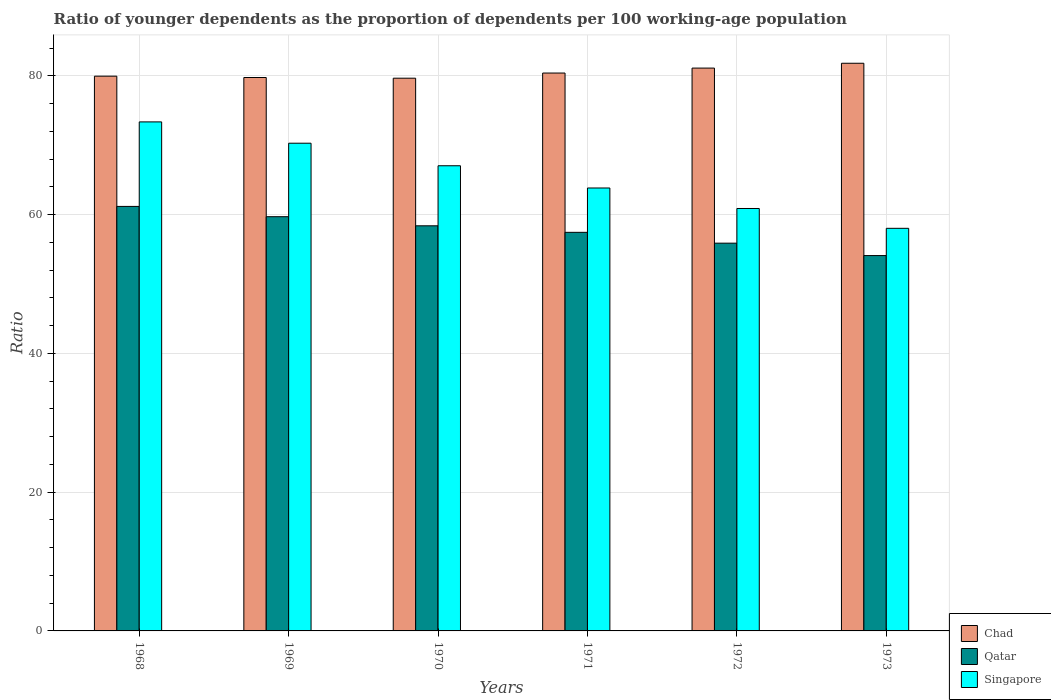Are the number of bars per tick equal to the number of legend labels?
Ensure brevity in your answer.  Yes. Are the number of bars on each tick of the X-axis equal?
Give a very brief answer. Yes. How many bars are there on the 1st tick from the left?
Offer a very short reply. 3. How many bars are there on the 6th tick from the right?
Provide a short and direct response. 3. What is the age dependency ratio(young) in Singapore in 1970?
Provide a short and direct response. 67.04. Across all years, what is the maximum age dependency ratio(young) in Qatar?
Make the answer very short. 61.18. Across all years, what is the minimum age dependency ratio(young) in Singapore?
Provide a succinct answer. 58.02. In which year was the age dependency ratio(young) in Singapore minimum?
Offer a very short reply. 1973. What is the total age dependency ratio(young) in Singapore in the graph?
Make the answer very short. 393.41. What is the difference between the age dependency ratio(young) in Chad in 1969 and that in 1971?
Provide a succinct answer. -0.64. What is the difference between the age dependency ratio(young) in Singapore in 1969 and the age dependency ratio(young) in Qatar in 1973?
Provide a short and direct response. 16.19. What is the average age dependency ratio(young) in Singapore per year?
Give a very brief answer. 65.57. In the year 1968, what is the difference between the age dependency ratio(young) in Qatar and age dependency ratio(young) in Chad?
Offer a terse response. -18.77. What is the ratio of the age dependency ratio(young) in Singapore in 1970 to that in 1971?
Your answer should be very brief. 1.05. Is the age dependency ratio(young) in Qatar in 1969 less than that in 1971?
Offer a very short reply. No. What is the difference between the highest and the second highest age dependency ratio(young) in Chad?
Ensure brevity in your answer.  0.7. What is the difference between the highest and the lowest age dependency ratio(young) in Chad?
Make the answer very short. 2.15. In how many years, is the age dependency ratio(young) in Qatar greater than the average age dependency ratio(young) in Qatar taken over all years?
Your answer should be very brief. 3. Is the sum of the age dependency ratio(young) in Qatar in 1968 and 1972 greater than the maximum age dependency ratio(young) in Singapore across all years?
Your response must be concise. Yes. What does the 2nd bar from the left in 1969 represents?
Make the answer very short. Qatar. What does the 1st bar from the right in 1968 represents?
Provide a succinct answer. Singapore. Is it the case that in every year, the sum of the age dependency ratio(young) in Chad and age dependency ratio(young) in Singapore is greater than the age dependency ratio(young) in Qatar?
Provide a succinct answer. Yes. How many bars are there?
Your response must be concise. 18. How many years are there in the graph?
Provide a succinct answer. 6. What is the difference between two consecutive major ticks on the Y-axis?
Provide a short and direct response. 20. Are the values on the major ticks of Y-axis written in scientific E-notation?
Provide a short and direct response. No. Where does the legend appear in the graph?
Your answer should be compact. Bottom right. How many legend labels are there?
Make the answer very short. 3. How are the legend labels stacked?
Your answer should be compact. Vertical. What is the title of the graph?
Your response must be concise. Ratio of younger dependents as the proportion of dependents per 100 working-age population. What is the label or title of the X-axis?
Offer a terse response. Years. What is the label or title of the Y-axis?
Offer a very short reply. Ratio. What is the Ratio of Chad in 1968?
Your answer should be compact. 79.95. What is the Ratio of Qatar in 1968?
Offer a very short reply. 61.18. What is the Ratio of Singapore in 1968?
Offer a terse response. 73.36. What is the Ratio of Chad in 1969?
Provide a short and direct response. 79.75. What is the Ratio of Qatar in 1969?
Ensure brevity in your answer.  59.69. What is the Ratio in Singapore in 1969?
Give a very brief answer. 70.28. What is the Ratio of Chad in 1970?
Keep it short and to the point. 79.65. What is the Ratio in Qatar in 1970?
Offer a very short reply. 58.38. What is the Ratio in Singapore in 1970?
Offer a very short reply. 67.04. What is the Ratio of Chad in 1971?
Make the answer very short. 80.4. What is the Ratio in Qatar in 1971?
Offer a terse response. 57.44. What is the Ratio in Singapore in 1971?
Provide a short and direct response. 63.83. What is the Ratio of Chad in 1972?
Provide a short and direct response. 81.11. What is the Ratio of Qatar in 1972?
Give a very brief answer. 55.88. What is the Ratio of Singapore in 1972?
Give a very brief answer. 60.88. What is the Ratio in Chad in 1973?
Ensure brevity in your answer.  81.81. What is the Ratio in Qatar in 1973?
Provide a short and direct response. 54.09. What is the Ratio in Singapore in 1973?
Make the answer very short. 58.02. Across all years, what is the maximum Ratio in Chad?
Provide a short and direct response. 81.81. Across all years, what is the maximum Ratio in Qatar?
Offer a very short reply. 61.18. Across all years, what is the maximum Ratio of Singapore?
Your response must be concise. 73.36. Across all years, what is the minimum Ratio of Chad?
Ensure brevity in your answer.  79.65. Across all years, what is the minimum Ratio in Qatar?
Provide a succinct answer. 54.09. Across all years, what is the minimum Ratio in Singapore?
Provide a succinct answer. 58.02. What is the total Ratio of Chad in the graph?
Your answer should be very brief. 482.67. What is the total Ratio of Qatar in the graph?
Give a very brief answer. 346.67. What is the total Ratio in Singapore in the graph?
Provide a succinct answer. 393.41. What is the difference between the Ratio of Chad in 1968 and that in 1969?
Offer a very short reply. 0.19. What is the difference between the Ratio of Qatar in 1968 and that in 1969?
Offer a terse response. 1.48. What is the difference between the Ratio of Singapore in 1968 and that in 1969?
Your response must be concise. 3.07. What is the difference between the Ratio in Chad in 1968 and that in 1970?
Your response must be concise. 0.29. What is the difference between the Ratio of Qatar in 1968 and that in 1970?
Make the answer very short. 2.8. What is the difference between the Ratio in Singapore in 1968 and that in 1970?
Keep it short and to the point. 6.32. What is the difference between the Ratio in Chad in 1968 and that in 1971?
Offer a very short reply. -0.45. What is the difference between the Ratio of Qatar in 1968 and that in 1971?
Give a very brief answer. 3.74. What is the difference between the Ratio of Singapore in 1968 and that in 1971?
Offer a terse response. 9.52. What is the difference between the Ratio in Chad in 1968 and that in 1972?
Make the answer very short. -1.16. What is the difference between the Ratio of Qatar in 1968 and that in 1972?
Ensure brevity in your answer.  5.3. What is the difference between the Ratio of Singapore in 1968 and that in 1972?
Offer a terse response. 12.48. What is the difference between the Ratio of Chad in 1968 and that in 1973?
Offer a very short reply. -1.86. What is the difference between the Ratio of Qatar in 1968 and that in 1973?
Offer a terse response. 7.09. What is the difference between the Ratio in Singapore in 1968 and that in 1973?
Your response must be concise. 15.34. What is the difference between the Ratio of Chad in 1969 and that in 1970?
Give a very brief answer. 0.1. What is the difference between the Ratio of Qatar in 1969 and that in 1970?
Give a very brief answer. 1.31. What is the difference between the Ratio of Singapore in 1969 and that in 1970?
Give a very brief answer. 3.25. What is the difference between the Ratio in Chad in 1969 and that in 1971?
Offer a terse response. -0.64. What is the difference between the Ratio of Qatar in 1969 and that in 1971?
Your answer should be very brief. 2.25. What is the difference between the Ratio in Singapore in 1969 and that in 1971?
Your response must be concise. 6.45. What is the difference between the Ratio in Chad in 1969 and that in 1972?
Ensure brevity in your answer.  -1.36. What is the difference between the Ratio of Qatar in 1969 and that in 1972?
Your answer should be compact. 3.81. What is the difference between the Ratio in Singapore in 1969 and that in 1972?
Make the answer very short. 9.41. What is the difference between the Ratio of Chad in 1969 and that in 1973?
Make the answer very short. -2.05. What is the difference between the Ratio in Qatar in 1969 and that in 1973?
Make the answer very short. 5.6. What is the difference between the Ratio of Singapore in 1969 and that in 1973?
Offer a terse response. 12.26. What is the difference between the Ratio in Chad in 1970 and that in 1971?
Offer a very short reply. -0.74. What is the difference between the Ratio of Qatar in 1970 and that in 1971?
Offer a very short reply. 0.94. What is the difference between the Ratio in Singapore in 1970 and that in 1971?
Make the answer very short. 3.2. What is the difference between the Ratio in Chad in 1970 and that in 1972?
Provide a succinct answer. -1.46. What is the difference between the Ratio of Qatar in 1970 and that in 1972?
Provide a succinct answer. 2.5. What is the difference between the Ratio in Singapore in 1970 and that in 1972?
Make the answer very short. 6.16. What is the difference between the Ratio of Chad in 1970 and that in 1973?
Provide a succinct answer. -2.15. What is the difference between the Ratio in Qatar in 1970 and that in 1973?
Offer a terse response. 4.29. What is the difference between the Ratio in Singapore in 1970 and that in 1973?
Your response must be concise. 9.02. What is the difference between the Ratio in Chad in 1971 and that in 1972?
Your answer should be very brief. -0.71. What is the difference between the Ratio of Qatar in 1971 and that in 1972?
Ensure brevity in your answer.  1.56. What is the difference between the Ratio in Singapore in 1971 and that in 1972?
Offer a terse response. 2.95. What is the difference between the Ratio of Chad in 1971 and that in 1973?
Provide a short and direct response. -1.41. What is the difference between the Ratio in Qatar in 1971 and that in 1973?
Ensure brevity in your answer.  3.35. What is the difference between the Ratio of Singapore in 1971 and that in 1973?
Keep it short and to the point. 5.81. What is the difference between the Ratio of Chad in 1972 and that in 1973?
Your response must be concise. -0.7. What is the difference between the Ratio of Qatar in 1972 and that in 1973?
Keep it short and to the point. 1.79. What is the difference between the Ratio of Singapore in 1972 and that in 1973?
Your answer should be very brief. 2.86. What is the difference between the Ratio in Chad in 1968 and the Ratio in Qatar in 1969?
Provide a succinct answer. 20.25. What is the difference between the Ratio in Chad in 1968 and the Ratio in Singapore in 1969?
Ensure brevity in your answer.  9.66. What is the difference between the Ratio of Qatar in 1968 and the Ratio of Singapore in 1969?
Keep it short and to the point. -9.11. What is the difference between the Ratio of Chad in 1968 and the Ratio of Qatar in 1970?
Give a very brief answer. 21.57. What is the difference between the Ratio in Chad in 1968 and the Ratio in Singapore in 1970?
Offer a very short reply. 12.91. What is the difference between the Ratio of Qatar in 1968 and the Ratio of Singapore in 1970?
Offer a terse response. -5.86. What is the difference between the Ratio in Chad in 1968 and the Ratio in Qatar in 1971?
Your answer should be very brief. 22.51. What is the difference between the Ratio of Chad in 1968 and the Ratio of Singapore in 1971?
Give a very brief answer. 16.12. What is the difference between the Ratio of Qatar in 1968 and the Ratio of Singapore in 1971?
Your answer should be compact. -2.65. What is the difference between the Ratio of Chad in 1968 and the Ratio of Qatar in 1972?
Make the answer very short. 24.07. What is the difference between the Ratio in Chad in 1968 and the Ratio in Singapore in 1972?
Your answer should be compact. 19.07. What is the difference between the Ratio of Qatar in 1968 and the Ratio of Singapore in 1972?
Your response must be concise. 0.3. What is the difference between the Ratio in Chad in 1968 and the Ratio in Qatar in 1973?
Your response must be concise. 25.86. What is the difference between the Ratio of Chad in 1968 and the Ratio of Singapore in 1973?
Make the answer very short. 21.93. What is the difference between the Ratio of Qatar in 1968 and the Ratio of Singapore in 1973?
Provide a succinct answer. 3.16. What is the difference between the Ratio in Chad in 1969 and the Ratio in Qatar in 1970?
Your response must be concise. 21.37. What is the difference between the Ratio in Chad in 1969 and the Ratio in Singapore in 1970?
Provide a short and direct response. 12.72. What is the difference between the Ratio in Qatar in 1969 and the Ratio in Singapore in 1970?
Your answer should be very brief. -7.34. What is the difference between the Ratio in Chad in 1969 and the Ratio in Qatar in 1971?
Your answer should be compact. 22.31. What is the difference between the Ratio of Chad in 1969 and the Ratio of Singapore in 1971?
Offer a very short reply. 15.92. What is the difference between the Ratio of Qatar in 1969 and the Ratio of Singapore in 1971?
Your answer should be compact. -4.14. What is the difference between the Ratio in Chad in 1969 and the Ratio in Qatar in 1972?
Your answer should be compact. 23.87. What is the difference between the Ratio of Chad in 1969 and the Ratio of Singapore in 1972?
Your answer should be very brief. 18.88. What is the difference between the Ratio in Qatar in 1969 and the Ratio in Singapore in 1972?
Provide a succinct answer. -1.18. What is the difference between the Ratio in Chad in 1969 and the Ratio in Qatar in 1973?
Your answer should be very brief. 25.66. What is the difference between the Ratio of Chad in 1969 and the Ratio of Singapore in 1973?
Provide a short and direct response. 21.73. What is the difference between the Ratio in Qatar in 1969 and the Ratio in Singapore in 1973?
Your response must be concise. 1.67. What is the difference between the Ratio in Chad in 1970 and the Ratio in Qatar in 1971?
Ensure brevity in your answer.  22.21. What is the difference between the Ratio in Chad in 1970 and the Ratio in Singapore in 1971?
Provide a succinct answer. 15.82. What is the difference between the Ratio of Qatar in 1970 and the Ratio of Singapore in 1971?
Your response must be concise. -5.45. What is the difference between the Ratio of Chad in 1970 and the Ratio of Qatar in 1972?
Ensure brevity in your answer.  23.77. What is the difference between the Ratio in Chad in 1970 and the Ratio in Singapore in 1972?
Ensure brevity in your answer.  18.78. What is the difference between the Ratio of Qatar in 1970 and the Ratio of Singapore in 1972?
Make the answer very short. -2.5. What is the difference between the Ratio in Chad in 1970 and the Ratio in Qatar in 1973?
Your answer should be very brief. 25.56. What is the difference between the Ratio in Chad in 1970 and the Ratio in Singapore in 1973?
Provide a succinct answer. 21.63. What is the difference between the Ratio in Qatar in 1970 and the Ratio in Singapore in 1973?
Give a very brief answer. 0.36. What is the difference between the Ratio of Chad in 1971 and the Ratio of Qatar in 1972?
Your answer should be compact. 24.52. What is the difference between the Ratio in Chad in 1971 and the Ratio in Singapore in 1972?
Your answer should be very brief. 19.52. What is the difference between the Ratio of Qatar in 1971 and the Ratio of Singapore in 1972?
Give a very brief answer. -3.44. What is the difference between the Ratio in Chad in 1971 and the Ratio in Qatar in 1973?
Give a very brief answer. 26.3. What is the difference between the Ratio in Chad in 1971 and the Ratio in Singapore in 1973?
Your answer should be very brief. 22.38. What is the difference between the Ratio in Qatar in 1971 and the Ratio in Singapore in 1973?
Your answer should be compact. -0.58. What is the difference between the Ratio in Chad in 1972 and the Ratio in Qatar in 1973?
Offer a terse response. 27.02. What is the difference between the Ratio of Chad in 1972 and the Ratio of Singapore in 1973?
Provide a short and direct response. 23.09. What is the difference between the Ratio of Qatar in 1972 and the Ratio of Singapore in 1973?
Provide a succinct answer. -2.14. What is the average Ratio of Chad per year?
Offer a terse response. 80.44. What is the average Ratio in Qatar per year?
Provide a short and direct response. 57.78. What is the average Ratio of Singapore per year?
Your response must be concise. 65.57. In the year 1968, what is the difference between the Ratio in Chad and Ratio in Qatar?
Your response must be concise. 18.77. In the year 1968, what is the difference between the Ratio in Chad and Ratio in Singapore?
Give a very brief answer. 6.59. In the year 1968, what is the difference between the Ratio of Qatar and Ratio of Singapore?
Keep it short and to the point. -12.18. In the year 1969, what is the difference between the Ratio of Chad and Ratio of Qatar?
Keep it short and to the point. 20.06. In the year 1969, what is the difference between the Ratio of Chad and Ratio of Singapore?
Offer a very short reply. 9.47. In the year 1969, what is the difference between the Ratio in Qatar and Ratio in Singapore?
Give a very brief answer. -10.59. In the year 1970, what is the difference between the Ratio of Chad and Ratio of Qatar?
Make the answer very short. 21.27. In the year 1970, what is the difference between the Ratio in Chad and Ratio in Singapore?
Keep it short and to the point. 12.62. In the year 1970, what is the difference between the Ratio in Qatar and Ratio in Singapore?
Your response must be concise. -8.65. In the year 1971, what is the difference between the Ratio in Chad and Ratio in Qatar?
Offer a very short reply. 22.96. In the year 1971, what is the difference between the Ratio of Chad and Ratio of Singapore?
Offer a terse response. 16.56. In the year 1971, what is the difference between the Ratio of Qatar and Ratio of Singapore?
Provide a succinct answer. -6.39. In the year 1972, what is the difference between the Ratio of Chad and Ratio of Qatar?
Provide a succinct answer. 25.23. In the year 1972, what is the difference between the Ratio of Chad and Ratio of Singapore?
Offer a terse response. 20.23. In the year 1972, what is the difference between the Ratio in Qatar and Ratio in Singapore?
Your response must be concise. -5. In the year 1973, what is the difference between the Ratio of Chad and Ratio of Qatar?
Your answer should be compact. 27.71. In the year 1973, what is the difference between the Ratio of Chad and Ratio of Singapore?
Your answer should be very brief. 23.79. In the year 1973, what is the difference between the Ratio of Qatar and Ratio of Singapore?
Your answer should be very brief. -3.93. What is the ratio of the Ratio in Qatar in 1968 to that in 1969?
Offer a terse response. 1.02. What is the ratio of the Ratio of Singapore in 1968 to that in 1969?
Provide a succinct answer. 1.04. What is the ratio of the Ratio in Chad in 1968 to that in 1970?
Make the answer very short. 1. What is the ratio of the Ratio in Qatar in 1968 to that in 1970?
Provide a succinct answer. 1.05. What is the ratio of the Ratio in Singapore in 1968 to that in 1970?
Offer a terse response. 1.09. What is the ratio of the Ratio in Qatar in 1968 to that in 1971?
Your response must be concise. 1.06. What is the ratio of the Ratio in Singapore in 1968 to that in 1971?
Keep it short and to the point. 1.15. What is the ratio of the Ratio in Chad in 1968 to that in 1972?
Provide a succinct answer. 0.99. What is the ratio of the Ratio of Qatar in 1968 to that in 1972?
Make the answer very short. 1.09. What is the ratio of the Ratio in Singapore in 1968 to that in 1972?
Offer a terse response. 1.21. What is the ratio of the Ratio of Chad in 1968 to that in 1973?
Give a very brief answer. 0.98. What is the ratio of the Ratio of Qatar in 1968 to that in 1973?
Offer a very short reply. 1.13. What is the ratio of the Ratio in Singapore in 1968 to that in 1973?
Keep it short and to the point. 1.26. What is the ratio of the Ratio of Chad in 1969 to that in 1970?
Make the answer very short. 1. What is the ratio of the Ratio of Qatar in 1969 to that in 1970?
Provide a short and direct response. 1.02. What is the ratio of the Ratio in Singapore in 1969 to that in 1970?
Give a very brief answer. 1.05. What is the ratio of the Ratio in Chad in 1969 to that in 1971?
Make the answer very short. 0.99. What is the ratio of the Ratio of Qatar in 1969 to that in 1971?
Your answer should be compact. 1.04. What is the ratio of the Ratio of Singapore in 1969 to that in 1971?
Provide a short and direct response. 1.1. What is the ratio of the Ratio of Chad in 1969 to that in 1972?
Provide a succinct answer. 0.98. What is the ratio of the Ratio in Qatar in 1969 to that in 1972?
Keep it short and to the point. 1.07. What is the ratio of the Ratio of Singapore in 1969 to that in 1972?
Provide a succinct answer. 1.15. What is the ratio of the Ratio in Chad in 1969 to that in 1973?
Ensure brevity in your answer.  0.97. What is the ratio of the Ratio of Qatar in 1969 to that in 1973?
Provide a succinct answer. 1.1. What is the ratio of the Ratio in Singapore in 1969 to that in 1973?
Give a very brief answer. 1.21. What is the ratio of the Ratio of Qatar in 1970 to that in 1971?
Give a very brief answer. 1.02. What is the ratio of the Ratio of Singapore in 1970 to that in 1971?
Your answer should be very brief. 1.05. What is the ratio of the Ratio in Qatar in 1970 to that in 1972?
Keep it short and to the point. 1.04. What is the ratio of the Ratio in Singapore in 1970 to that in 1972?
Offer a terse response. 1.1. What is the ratio of the Ratio in Chad in 1970 to that in 1973?
Ensure brevity in your answer.  0.97. What is the ratio of the Ratio in Qatar in 1970 to that in 1973?
Provide a succinct answer. 1.08. What is the ratio of the Ratio of Singapore in 1970 to that in 1973?
Your response must be concise. 1.16. What is the ratio of the Ratio in Qatar in 1971 to that in 1972?
Offer a very short reply. 1.03. What is the ratio of the Ratio of Singapore in 1971 to that in 1972?
Offer a very short reply. 1.05. What is the ratio of the Ratio of Chad in 1971 to that in 1973?
Your answer should be very brief. 0.98. What is the ratio of the Ratio in Qatar in 1971 to that in 1973?
Your answer should be very brief. 1.06. What is the ratio of the Ratio of Singapore in 1971 to that in 1973?
Provide a short and direct response. 1.1. What is the ratio of the Ratio of Chad in 1972 to that in 1973?
Ensure brevity in your answer.  0.99. What is the ratio of the Ratio in Qatar in 1972 to that in 1973?
Offer a very short reply. 1.03. What is the ratio of the Ratio in Singapore in 1972 to that in 1973?
Your answer should be very brief. 1.05. What is the difference between the highest and the second highest Ratio in Chad?
Provide a succinct answer. 0.7. What is the difference between the highest and the second highest Ratio of Qatar?
Make the answer very short. 1.48. What is the difference between the highest and the second highest Ratio of Singapore?
Offer a very short reply. 3.07. What is the difference between the highest and the lowest Ratio in Chad?
Ensure brevity in your answer.  2.15. What is the difference between the highest and the lowest Ratio of Qatar?
Your answer should be very brief. 7.09. What is the difference between the highest and the lowest Ratio in Singapore?
Your response must be concise. 15.34. 